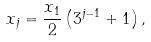Convert formula to latex. <formula><loc_0><loc_0><loc_500><loc_500>x _ { j } = \frac { x _ { 1 } } { 2 } \left ( 3 ^ { j - 1 } + 1 \right ) ,</formula> 